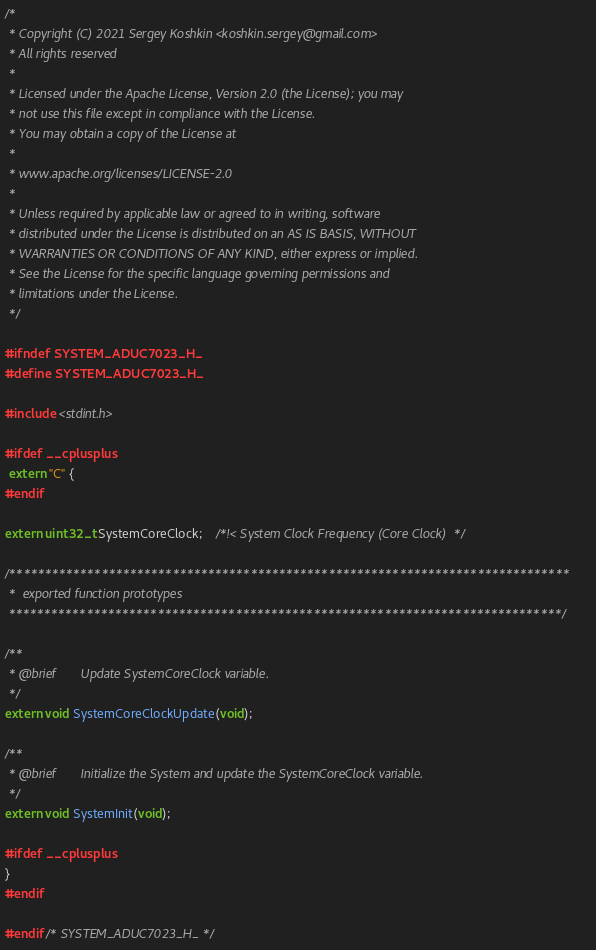Convert code to text. <code><loc_0><loc_0><loc_500><loc_500><_C_>/*
 * Copyright (C) 2021 Sergey Koshkin <koshkin.sergey@gmail.com>
 * All rights reserved
 *
 * Licensed under the Apache License, Version 2.0 (the License); you may
 * not use this file except in compliance with the License.
 * You may obtain a copy of the License at
 *
 * www.apache.org/licenses/LICENSE-2.0
 *
 * Unless required by applicable law or agreed to in writing, software
 * distributed under the License is distributed on an AS IS BASIS, WITHOUT
 * WARRANTIES OR CONDITIONS OF ANY KIND, either express or implied.
 * See the License for the specific language governing permissions and
 * limitations under the License.
 */

#ifndef SYSTEM_ADUC7023_H_
#define SYSTEM_ADUC7023_H_

#include <stdint.h>

#ifdef __cplusplus
 extern "C" {
#endif

extern uint32_t SystemCoreClock;    /*!< System Clock Frequency (Core Clock)  */

/*******************************************************************************
 *  exported function prototypes
 ******************************************************************************/

/**
 * @brief       Update SystemCoreClock variable.
 */
extern void SystemCoreClockUpdate(void);

/**
 * @brief       Initialize the System and update the SystemCoreClock variable.
 */
extern void SystemInit(void);

#ifdef __cplusplus
}
#endif

#endif /* SYSTEM_ADUC7023_H_ */
</code> 